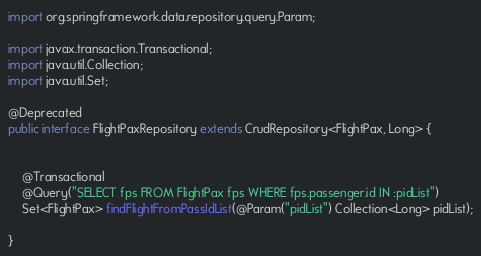Convert code to text. <code><loc_0><loc_0><loc_500><loc_500><_Java_>import org.springframework.data.repository.query.Param;

import javax.transaction.Transactional;
import java.util.Collection;
import java.util.Set;

@Deprecated
public interface FlightPaxRepository extends CrudRepository<FlightPax, Long> {


	@Transactional
	@Query("SELECT fps FROM FlightPax fps WHERE fps.passenger.id IN :pidList")
	Set<FlightPax> findFlightFromPassIdList(@Param("pidList") Collection<Long> pidList);

}
</code> 